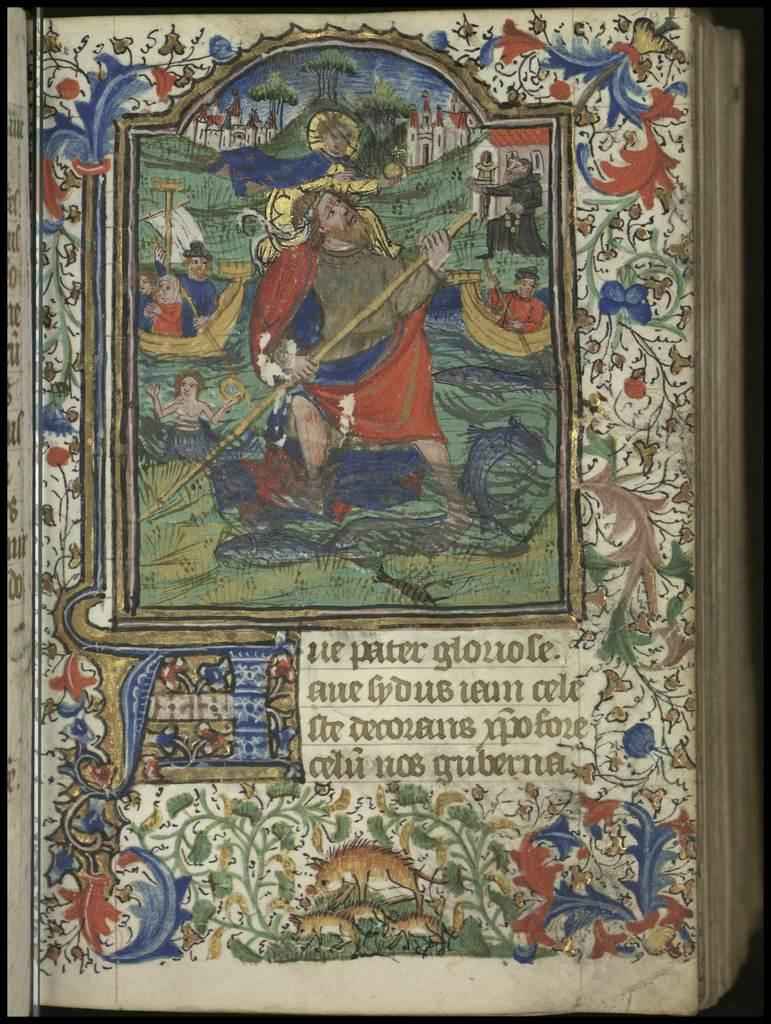Provide a one-sentence caption for the provided image. The blue red and white book features a man named Peter. 